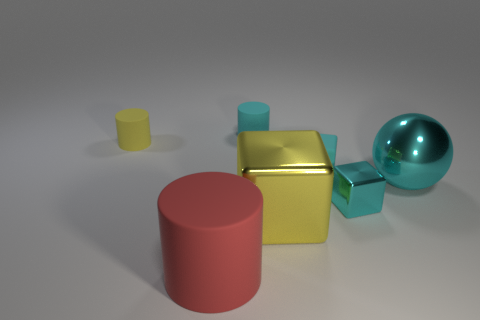How many other tiny blocks are the same color as the matte cube?
Ensure brevity in your answer.  1. How many things are either blocks that are to the left of the small cyan shiny object or big cylinders that are in front of the yellow metallic thing?
Provide a short and direct response. 3. Are there fewer rubber things that are on the right side of the big yellow block than cyan blocks?
Offer a terse response. Yes. Is there a cyan object of the same size as the cyan metallic sphere?
Give a very brief answer. No. What color is the small shiny cube?
Provide a short and direct response. Cyan. Is the size of the matte block the same as the cyan cylinder?
Offer a very short reply. Yes. What number of objects are large cyan metallic spheres or yellow shiny cubes?
Provide a succinct answer. 2. Are there an equal number of cubes that are on the right side of the big cyan shiny object and tiny cyan metal things?
Offer a very short reply. No. There is a small matte cylinder behind the yellow thing that is on the left side of the large matte cylinder; is there a large cyan shiny thing that is left of it?
Provide a short and direct response. No. There is a big object that is made of the same material as the tiny yellow thing; what is its color?
Provide a succinct answer. Red. 